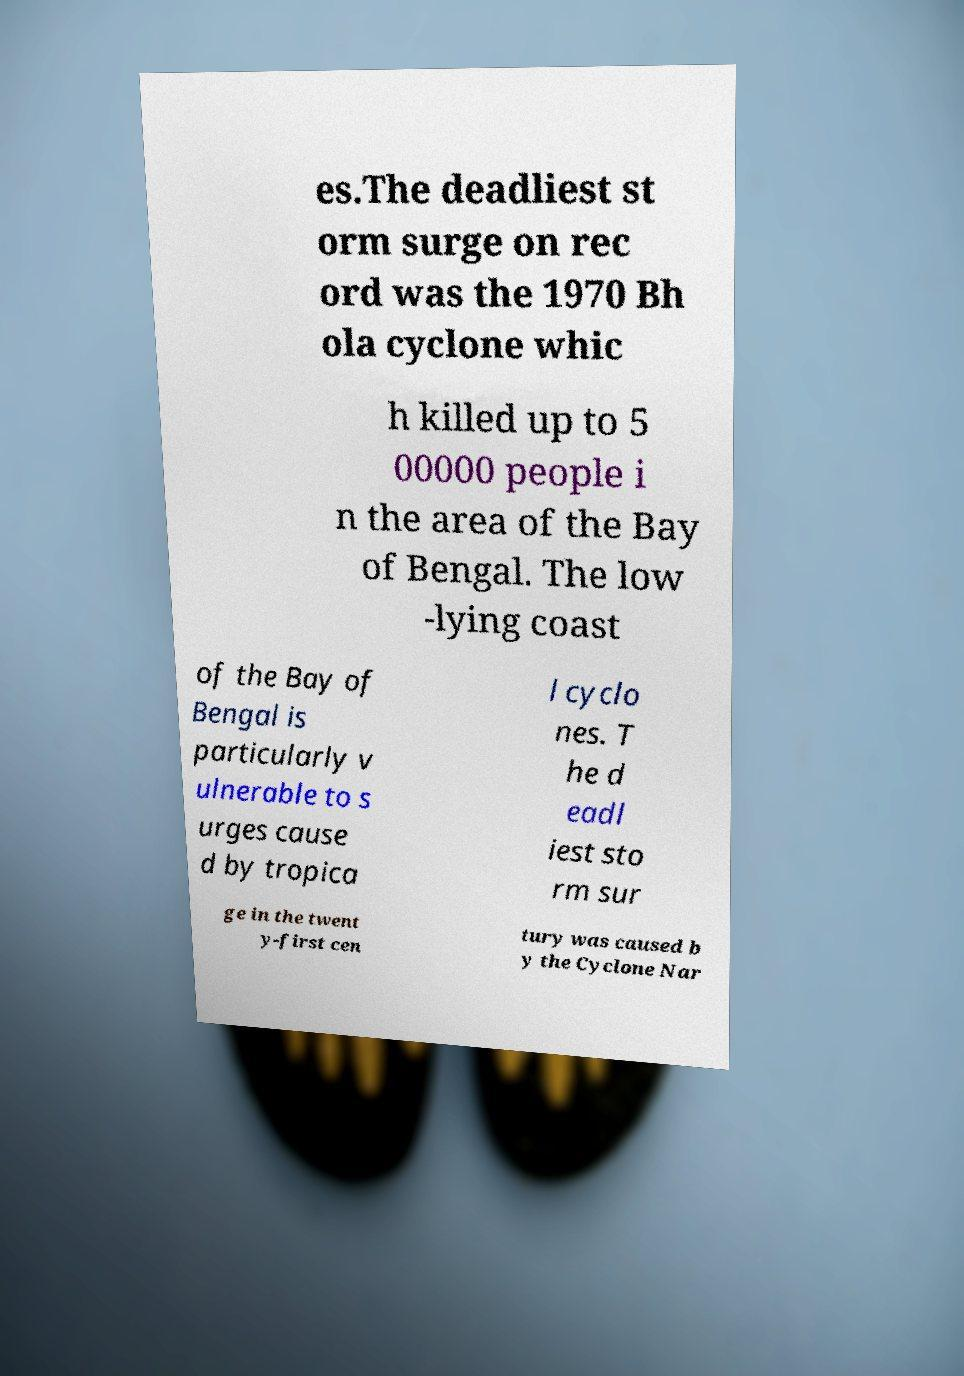Can you read and provide the text displayed in the image?This photo seems to have some interesting text. Can you extract and type it out for me? es.The deadliest st orm surge on rec ord was the 1970 Bh ola cyclone whic h killed up to 5 00000 people i n the area of the Bay of Bengal. The low -lying coast of the Bay of Bengal is particularly v ulnerable to s urges cause d by tropica l cyclo nes. T he d eadl iest sto rm sur ge in the twent y-first cen tury was caused b y the Cyclone Nar 